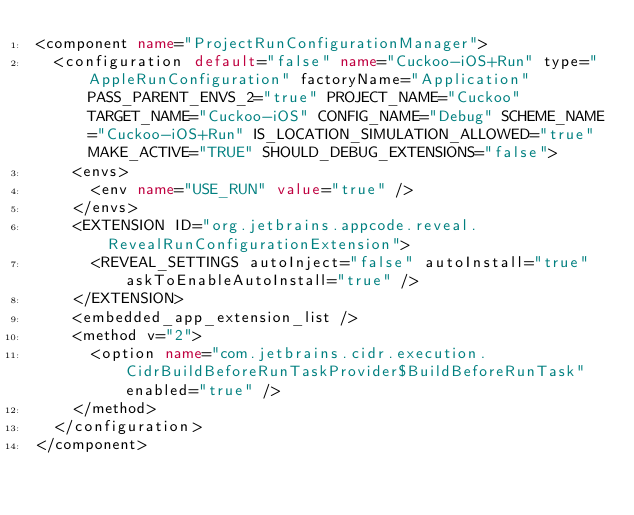Convert code to text. <code><loc_0><loc_0><loc_500><loc_500><_XML_><component name="ProjectRunConfigurationManager">
  <configuration default="false" name="Cuckoo-iOS+Run" type="AppleRunConfiguration" factoryName="Application" PASS_PARENT_ENVS_2="true" PROJECT_NAME="Cuckoo" TARGET_NAME="Cuckoo-iOS" CONFIG_NAME="Debug" SCHEME_NAME="Cuckoo-iOS+Run" IS_LOCATION_SIMULATION_ALLOWED="true" MAKE_ACTIVE="TRUE" SHOULD_DEBUG_EXTENSIONS="false">
    <envs>
      <env name="USE_RUN" value="true" />
    </envs>
    <EXTENSION ID="org.jetbrains.appcode.reveal.RevealRunConfigurationExtension">
      <REVEAL_SETTINGS autoInject="false" autoInstall="true" askToEnableAutoInstall="true" />
    </EXTENSION>
    <embedded_app_extension_list />
    <method v="2">
      <option name="com.jetbrains.cidr.execution.CidrBuildBeforeRunTaskProvider$BuildBeforeRunTask" enabled="true" />
    </method>
  </configuration>
</component></code> 